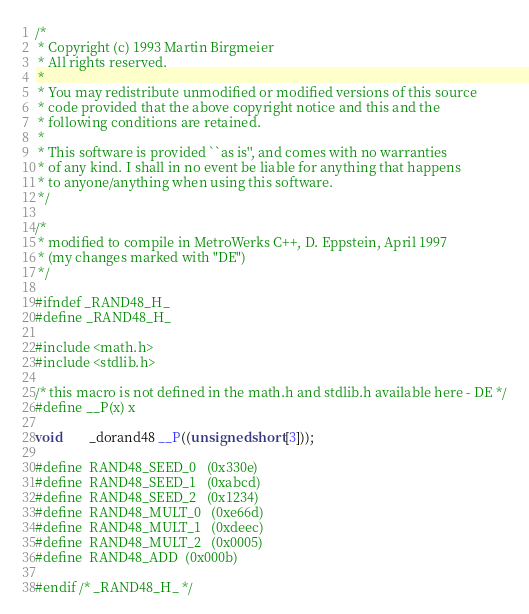Convert code to text. <code><loc_0><loc_0><loc_500><loc_500><_C_>/*
 * Copyright (c) 1993 Martin Birgmeier
 * All rights reserved.
 *
 * You may redistribute unmodified or modified versions of this source
 * code provided that the above copyright notice and this and the
 * following conditions are retained.
 *
 * This software is provided ``as is'', and comes with no warranties
 * of any kind. I shall in no event be liable for anything that happens
 * to anyone/anything when using this software.
 */
 
/*
 * modified to compile in MetroWerks C++, D. Eppstein, April 1997
 * (my changes marked with "DE")
 */

#ifndef _RAND48_H_
#define _RAND48_H_

#include <math.h>
#include <stdlib.h>

/* this macro is not defined in the math.h and stdlib.h available here - DE */
#define __P(x) x

void		_dorand48 __P((unsigned short[3]));

#define	RAND48_SEED_0	(0x330e)
#define	RAND48_SEED_1	(0xabcd)
#define	RAND48_SEED_2	(0x1234)
#define	RAND48_MULT_0	(0xe66d)
#define	RAND48_MULT_1	(0xdeec)
#define	RAND48_MULT_2	(0x0005)
#define	RAND48_ADD	(0x000b)

#endif /* _RAND48_H_ */
</code> 